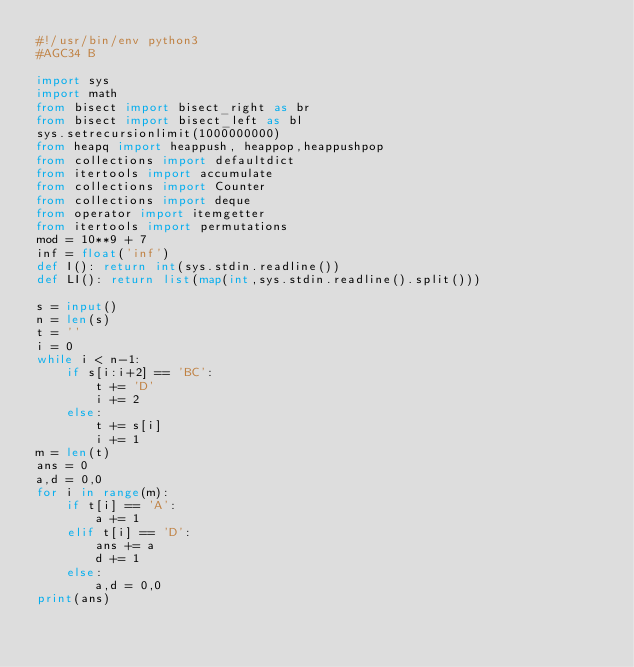Convert code to text. <code><loc_0><loc_0><loc_500><loc_500><_Python_>#!/usr/bin/env python3
#AGC34 B

import sys
import math
from bisect import bisect_right as br
from bisect import bisect_left as bl
sys.setrecursionlimit(1000000000)
from heapq import heappush, heappop,heappushpop
from collections import defaultdict
from itertools import accumulate
from collections import Counter
from collections import deque
from operator import itemgetter
from itertools import permutations
mod = 10**9 + 7
inf = float('inf')
def I(): return int(sys.stdin.readline())
def LI(): return list(map(int,sys.stdin.readline().split()))

s = input()
n = len(s)
t = ''
i = 0
while i < n-1:
    if s[i:i+2] == 'BC':
        t += 'D'
        i += 2
    else:
        t += s[i]
        i += 1
m = len(t)
ans = 0
a,d = 0,0
for i in range(m):
    if t[i] == 'A':
        a += 1
    elif t[i] == 'D':
        ans += a
        d += 1
    else:
        a,d = 0,0
print(ans)
</code> 